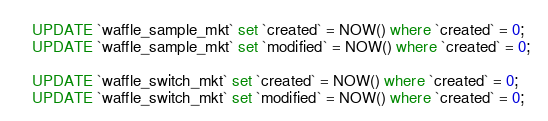<code> <loc_0><loc_0><loc_500><loc_500><_SQL_>UPDATE `waffle_sample_mkt` set `created` = NOW() where `created` = 0;
UPDATE `waffle_sample_mkt` set `modified` = NOW() where `created` = 0;

UPDATE `waffle_switch_mkt` set `created` = NOW() where `created` = 0;
UPDATE `waffle_switch_mkt` set `modified` = NOW() where `created` = 0;



</code> 